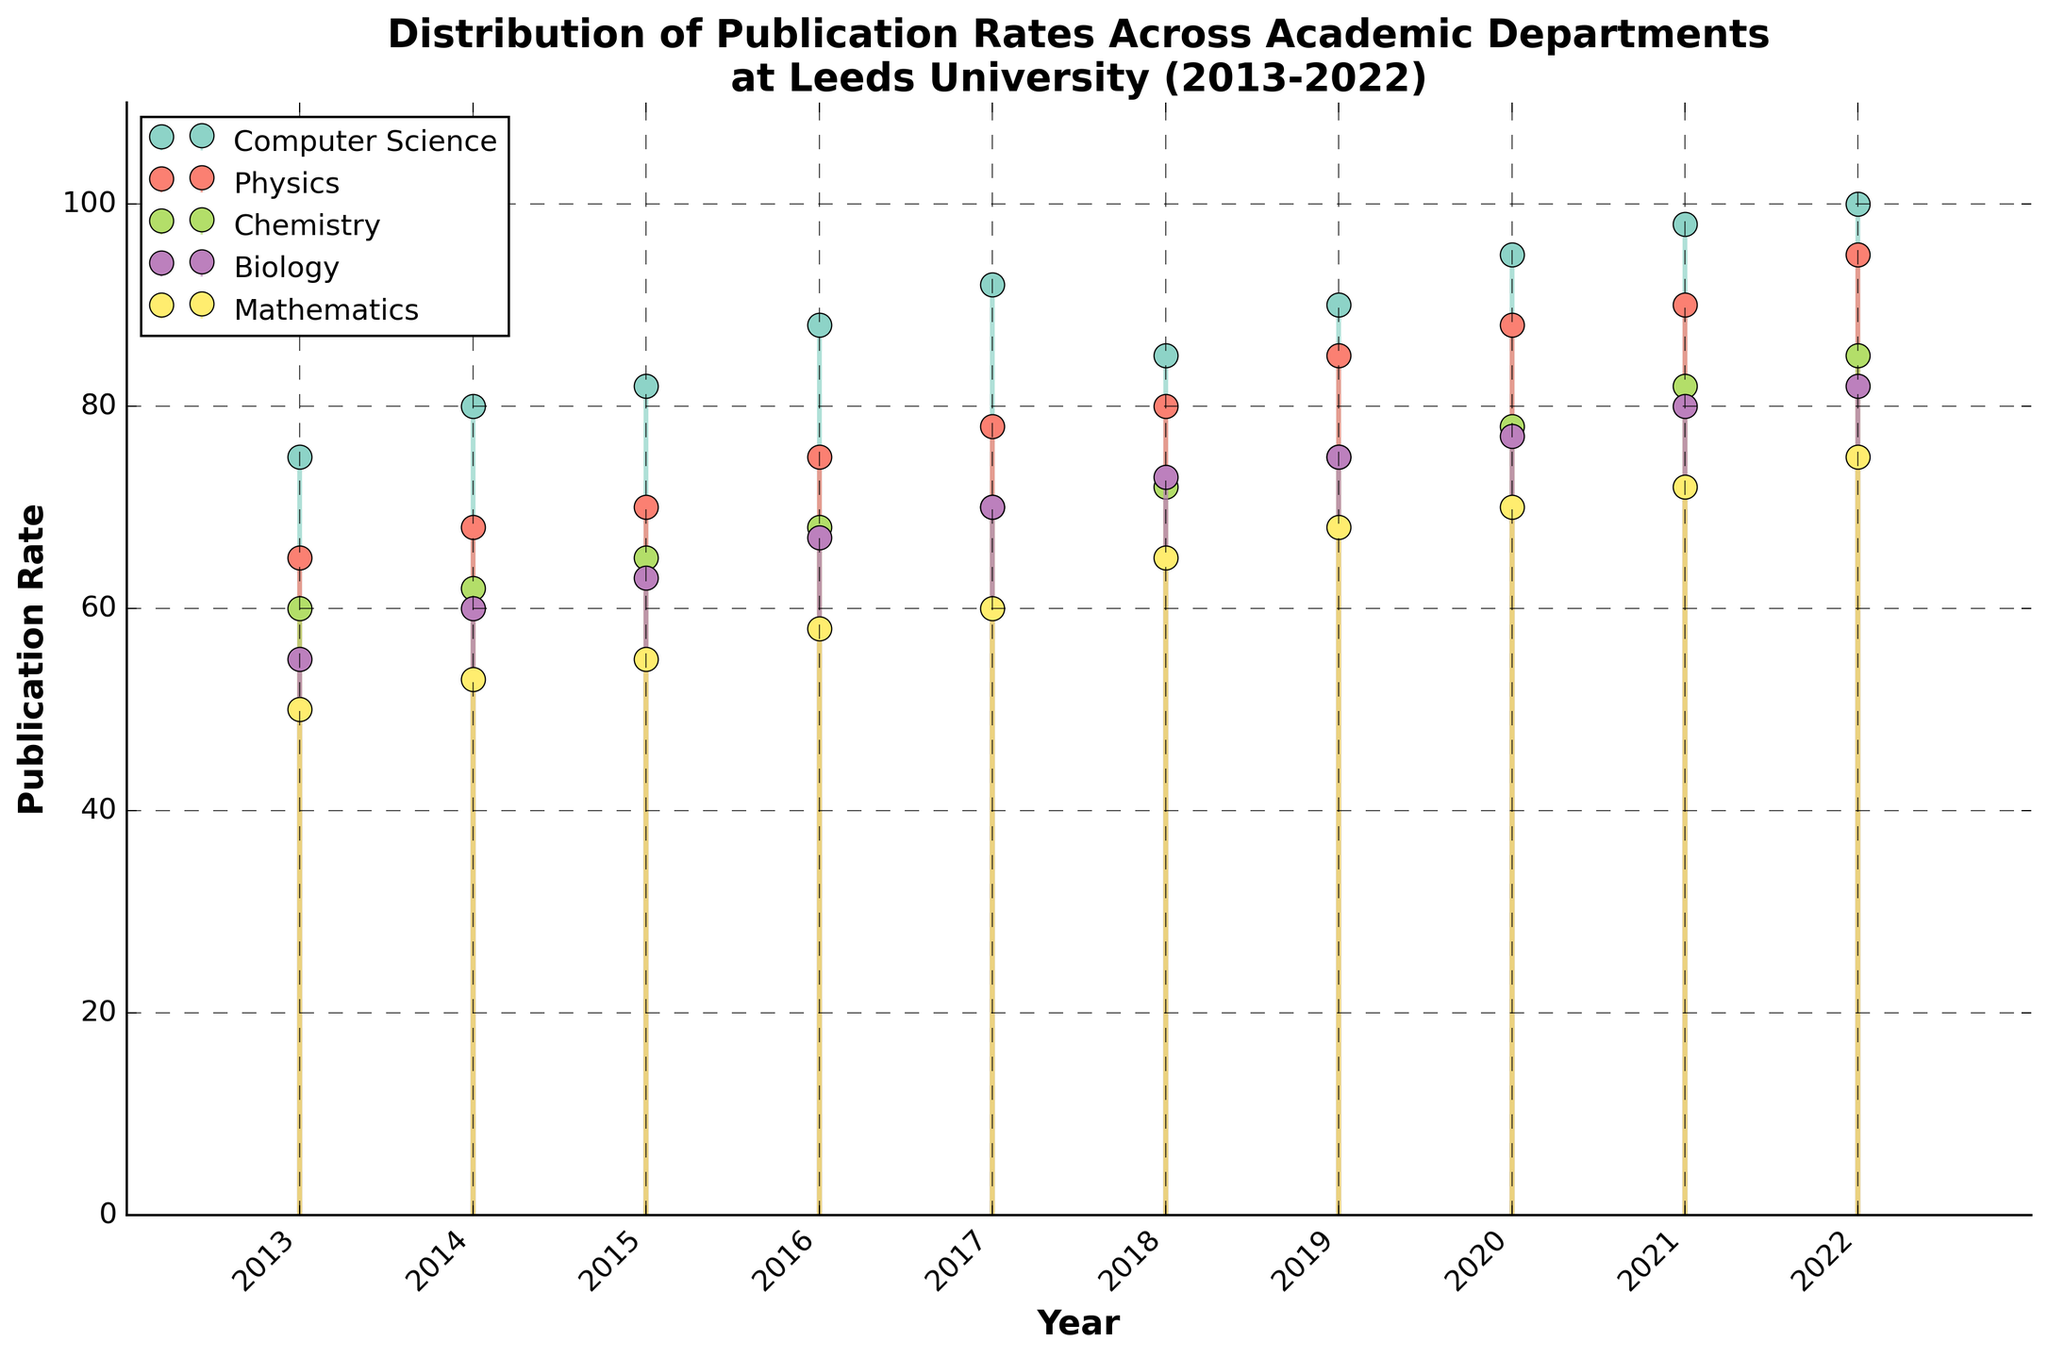What is the title of the figure? The title is the descriptive text at the top of the figure. It summarizes the content covered by the figure and is typically larger in font size and bolded. In this case, it reads, "Distribution of Publication Rates Across Academic Departments at Leeds University (2013-2022)."
Answer: Distribution of Publication Rates Across Academic Departments at Leeds University (2013-2022) Which department had the highest publication rate in 2022? To determine which department had the highest publication rate in 2022, look at the marker positions for each department on the x-axis at 2022. The department with the highest marker is the one with the highest publication rate in that year.
Answer: Computer Science What was the publication rate for the Physics department in 2015? Locate the stem line for the Physics department at the x-axis position for 2015, then follow the line up to the y-axis to find the corresponding publication rate.
Answer: 70 Which department experienced the largest increase in publication rates from 2013 to 2022? To identify the department with the largest increase, calculate the difference between the publication rates in 2013 and 2022 for each department. The department with the greatest difference experienced the largest increase. Computer Science went from 75 to 100 (increase of 25). Physics went from 65 to 95 (increase of 30). Chemistry went from 60 to 85 (increase of 25). Biology went from 55 to 82 (increase of 27). Mathematics went from 50 to 75 (increase of 25).
Answer: Physics Which two departments showed the most similar publication rates in 2020? Check the publication rates of all departments in 2020, noting the values on the y-axis. Identify the two departments whose rates are closest to each other. For 2020, Computer Science is 95, Physics is 88, Chemistry is 78, Biology is 77, and Mathematics is 70. The closest values are Biology and Chemistry at 77 and 78, respectively.
Answer: Biology and Chemistry What patterns/trends can be observed in the publication rates of the Computer Science department over the decade? Look at the stem lines for the Computer Science department across the entire x-axis range (2013 to 2022), noting the general direction and any fluctuations. The trend should include both overall increases and any periods of decline or stability. From 2013 to 2022, the Computer Science department shows an overall upward trend with slight fluctuations, primarily increasing each year.
Answer: Mostly increasing with slight fluctuations How does the publication rate of Mathematics in 2017 compare with that of Biology in 2017? To compare the two values, locate the marker for Mathematics in 2017 and the marker for Biology in 2017. Mathematics had a publication rate of 60, while Biology had a rate of 70.
Answer: Biology had a higher rate What years did Chemistry show a publication rate above 70? Examine the y-axis values for the Chemistry department and note the years where the publication rate exceeds 70. These thresholds are crossed starting from 2018 onwards (2018-2022).
Answer: 2018, 2019, 2020, 2021, 2022 What was the average publication rate of the Physics department over the entire decade? Calculate the sum of the publication rates for Physics from 2013 to 2022, then divide by the number of years (10). The sum is 65 + 68 + 70 + 75 + 78 + 80 + 85 + 88 + 90 + 95 = 794. The average is 794/10.
Answer: 79.4 In which year did Biology see a notable increase in the publication rate? Identify the year(s) where the publication rate for Biology shows a significant jump compared to the previous year by looking at the difference between consecutive markers. The most notable year-to-year increase is from 2016 to 2017, where it jumped from 67 to 70, and from 2020 to 2021, where it increased from 77 to 80.
Answer: 2017 and 2021 